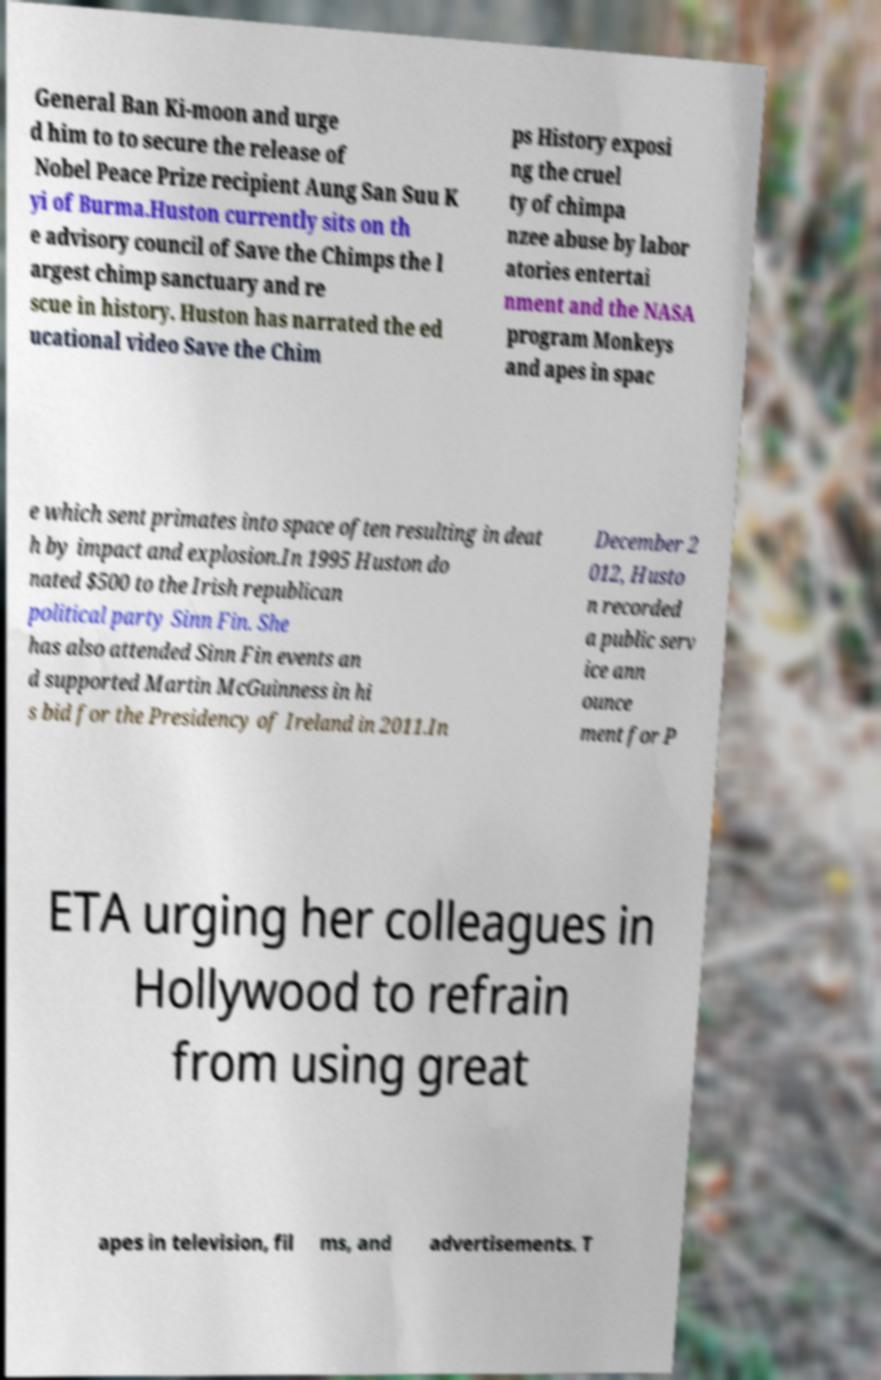Could you extract and type out the text from this image? General Ban Ki-moon and urge d him to to secure the release of Nobel Peace Prize recipient Aung San Suu K yi of Burma.Huston currently sits on th e advisory council of Save the Chimps the l argest chimp sanctuary and re scue in history. Huston has narrated the ed ucational video Save the Chim ps History exposi ng the cruel ty of chimpa nzee abuse by labor atories entertai nment and the NASA program Monkeys and apes in spac e which sent primates into space often resulting in deat h by impact and explosion.In 1995 Huston do nated $500 to the Irish republican political party Sinn Fin. She has also attended Sinn Fin events an d supported Martin McGuinness in hi s bid for the Presidency of Ireland in 2011.In December 2 012, Husto n recorded a public serv ice ann ounce ment for P ETA urging her colleagues in Hollywood to refrain from using great apes in television, fil ms, and advertisements. T 